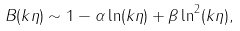Convert formula to latex. <formula><loc_0><loc_0><loc_500><loc_500>B ( k \eta ) \sim 1 - \alpha \ln ( k \eta ) + \beta \ln ^ { 2 } ( k \eta ) ,</formula> 